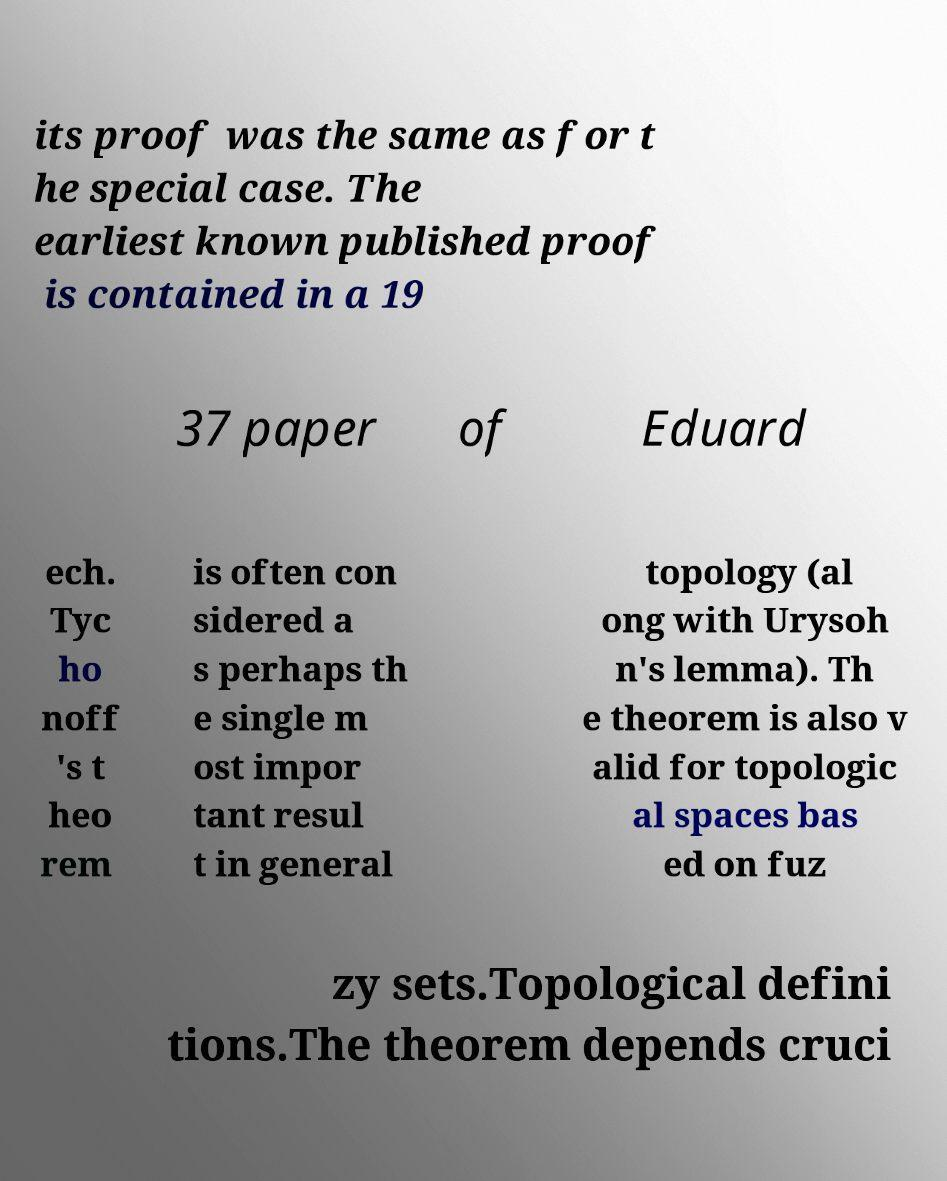I need the written content from this picture converted into text. Can you do that? its proof was the same as for t he special case. The earliest known published proof is contained in a 19 37 paper of Eduard ech. Tyc ho noff 's t heo rem is often con sidered a s perhaps th e single m ost impor tant resul t in general topology (al ong with Urysoh n's lemma). Th e theorem is also v alid for topologic al spaces bas ed on fuz zy sets.Topological defini tions.The theorem depends cruci 